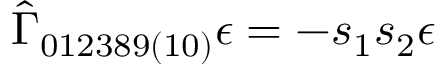Convert formula to latex. <formula><loc_0><loc_0><loc_500><loc_500>\hat { \Gamma } _ { 0 1 2 3 8 9 ( 1 0 ) } \epsilon = - s _ { 1 } s _ { 2 } \epsilon</formula> 